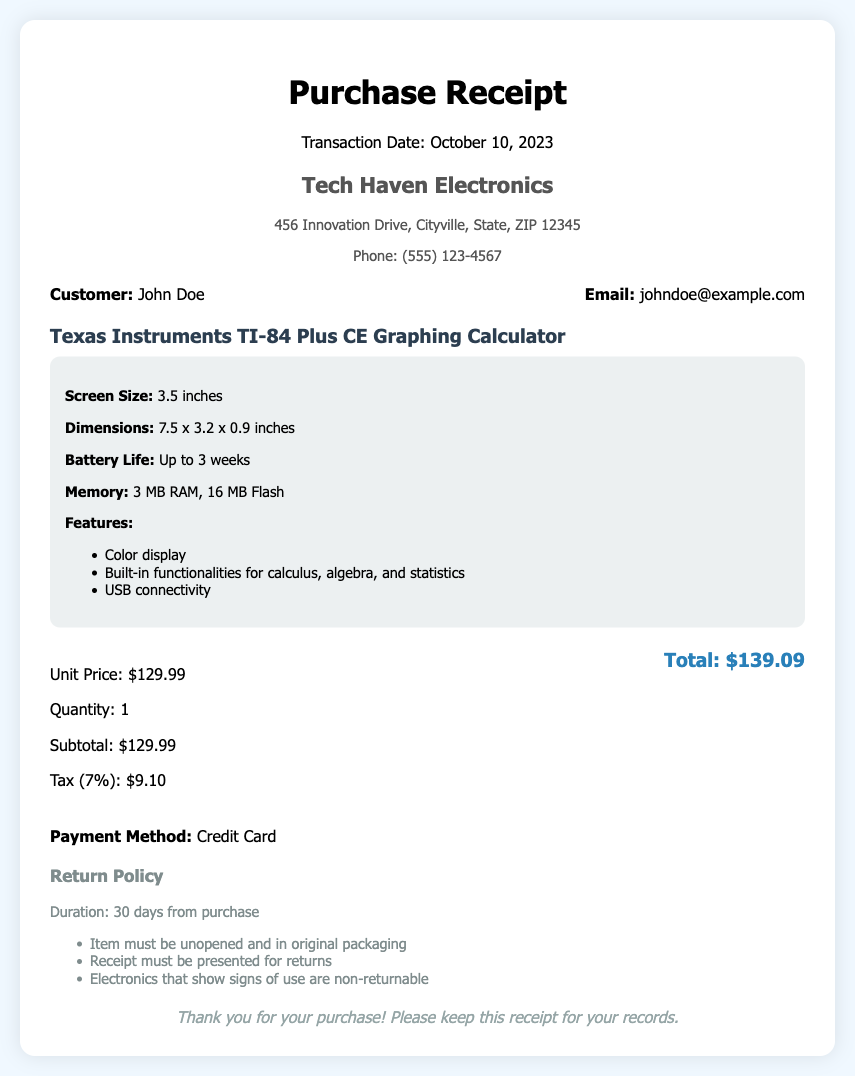What is the transaction date? The transaction date is clearly stated in the document as October 10, 2023.
Answer: October 10, 2023 What is the name of the calculator? The document specifies the name of the calculator as Texas Instruments TI-84 Plus CE Graphing Calculator.
Answer: Texas Instruments TI-84 Plus CE Graphing Calculator What is the subtotal amount? The subtotal amount is listed in the price breakdown section of the document as $129.99.
Answer: $129.99 What is the tax percentage applied? The document mentions a tax of 7%, which is applied to the purchase.
Answer: 7% How long is the return policy duration? The return policy specifies a duration of 30 days from purchase for returning the item.
Answer: 30 days What is the customer's email? The document provides the customer's email as johndoe@example.com.
Answer: johndoe@example.com What items are non-returnable according to the policy? The return policy states that electronics that show signs of use are non-returnable.
Answer: Electronics that show signs of use What payment method was used for the purchase? The payment method is indicated in the document as Credit Card.
Answer: Credit Card What is the total amount paid? The total amount paid is the sum of subtotal and tax listed as $139.09.
Answer: $139.09 